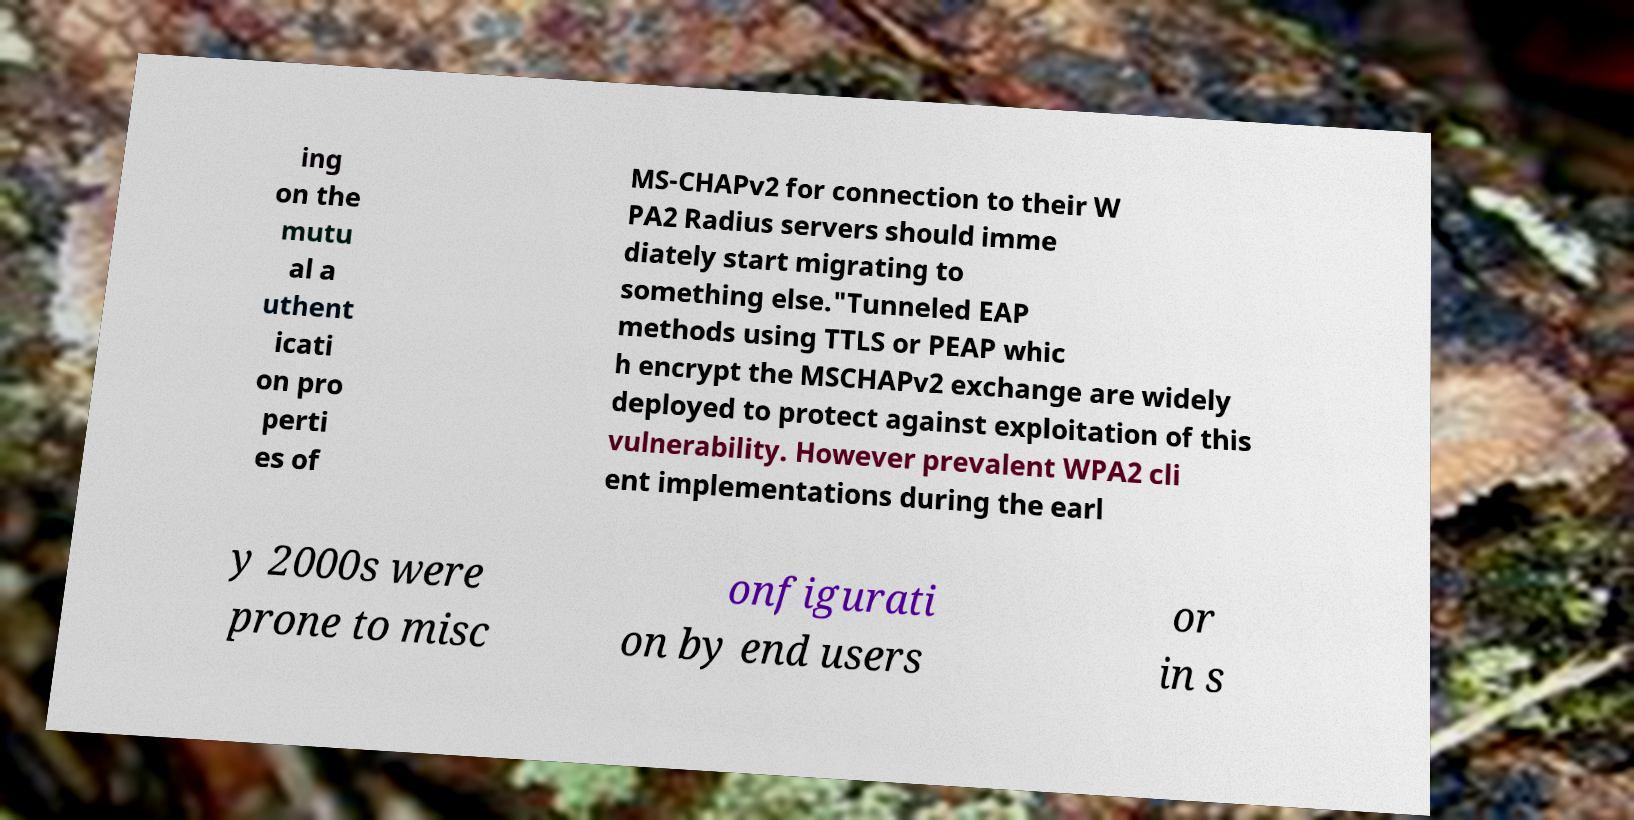Can you accurately transcribe the text from the provided image for me? ing on the mutu al a uthent icati on pro perti es of MS-CHAPv2 for connection to their W PA2 Radius servers should imme diately start migrating to something else."Tunneled EAP methods using TTLS or PEAP whic h encrypt the MSCHAPv2 exchange are widely deployed to protect against exploitation of this vulnerability. However prevalent WPA2 cli ent implementations during the earl y 2000s were prone to misc onfigurati on by end users or in s 